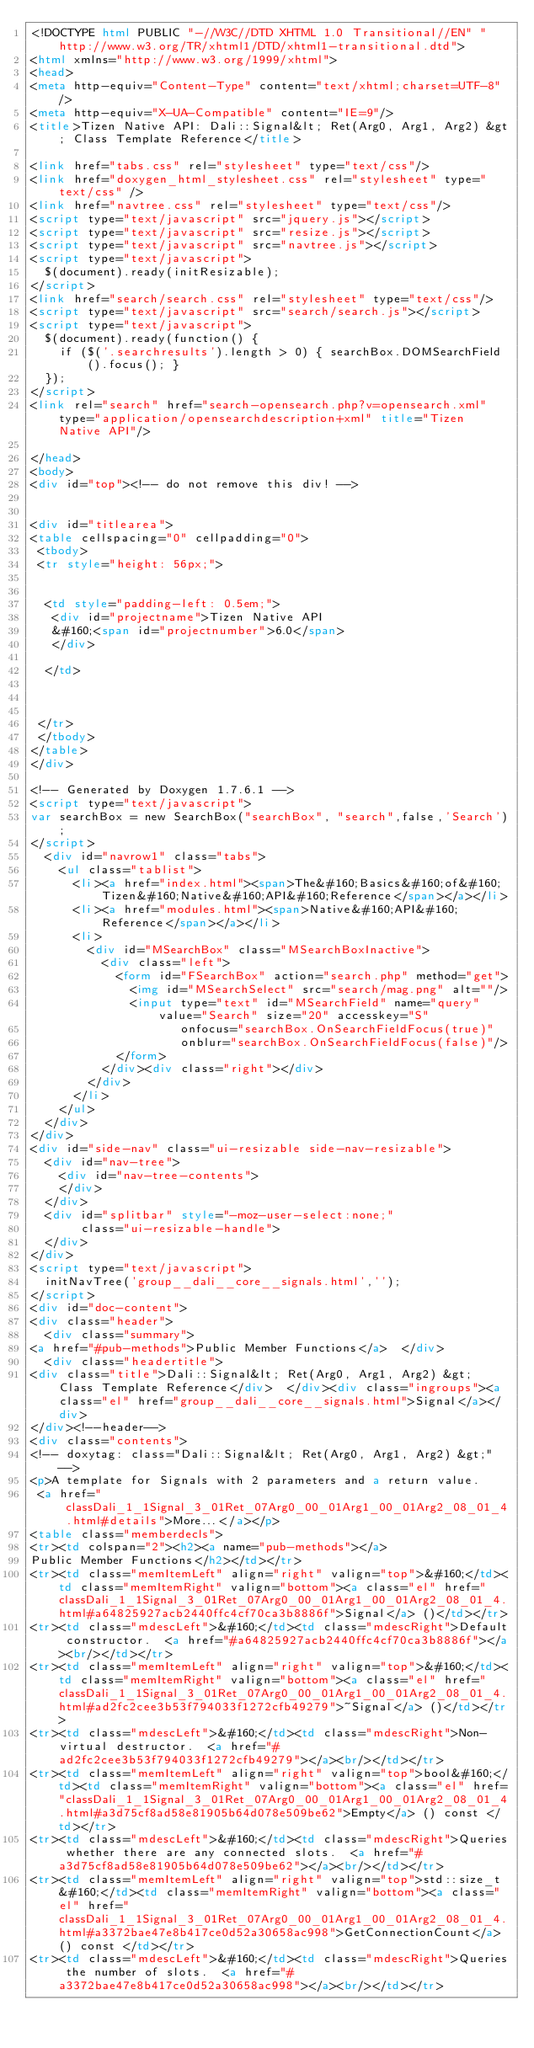<code> <loc_0><loc_0><loc_500><loc_500><_HTML_><!DOCTYPE html PUBLIC "-//W3C//DTD XHTML 1.0 Transitional//EN" "http://www.w3.org/TR/xhtml1/DTD/xhtml1-transitional.dtd">
<html xmlns="http://www.w3.org/1999/xhtml">
<head>
<meta http-equiv="Content-Type" content="text/xhtml;charset=UTF-8"/>
<meta http-equiv="X-UA-Compatible" content="IE=9"/>
<title>Tizen Native API: Dali::Signal&lt; Ret(Arg0, Arg1, Arg2) &gt; Class Template Reference</title>

<link href="tabs.css" rel="stylesheet" type="text/css"/>
<link href="doxygen_html_stylesheet.css" rel="stylesheet" type="text/css" />
<link href="navtree.css" rel="stylesheet" type="text/css"/>
<script type="text/javascript" src="jquery.js"></script>
<script type="text/javascript" src="resize.js"></script>
<script type="text/javascript" src="navtree.js"></script>
<script type="text/javascript">
  $(document).ready(initResizable);
</script>
<link href="search/search.css" rel="stylesheet" type="text/css"/>
<script type="text/javascript" src="search/search.js"></script>
<script type="text/javascript">
  $(document).ready(function() {
    if ($('.searchresults').length > 0) { searchBox.DOMSearchField().focus(); }
  });
</script>
<link rel="search" href="search-opensearch.php?v=opensearch.xml" type="application/opensearchdescription+xml" title="Tizen Native API"/>

</head>
<body>
<div id="top"><!-- do not remove this div! -->


<div id="titlearea">
<table cellspacing="0" cellpadding="0">
 <tbody>
 <tr style="height: 56px;">
  
  
  <td style="padding-left: 0.5em;">
   <div id="projectname">Tizen Native API
   &#160;<span id="projectnumber">6.0</span>
   </div>
   
  </td>
  
  
  
 </tr>
 </tbody>
</table>
</div>

<!-- Generated by Doxygen 1.7.6.1 -->
<script type="text/javascript">
var searchBox = new SearchBox("searchBox", "search",false,'Search');
</script>
  <div id="navrow1" class="tabs">
    <ul class="tablist">
      <li><a href="index.html"><span>The&#160;Basics&#160;of&#160;Tizen&#160;Native&#160;API&#160;Reference</span></a></li>
      <li><a href="modules.html"><span>Native&#160;API&#160;Reference</span></a></li>
      <li>
        <div id="MSearchBox" class="MSearchBoxInactive">
          <div class="left">
            <form id="FSearchBox" action="search.php" method="get">
              <img id="MSearchSelect" src="search/mag.png" alt=""/>
              <input type="text" id="MSearchField" name="query" value="Search" size="20" accesskey="S" 
                     onfocus="searchBox.OnSearchFieldFocus(true)" 
                     onblur="searchBox.OnSearchFieldFocus(false)"/>
            </form>
          </div><div class="right"></div>
        </div>
      </li>
    </ul>
  </div>
</div>
<div id="side-nav" class="ui-resizable side-nav-resizable">
  <div id="nav-tree">
    <div id="nav-tree-contents">
    </div>
  </div>
  <div id="splitbar" style="-moz-user-select:none;" 
       class="ui-resizable-handle">
  </div>
</div>
<script type="text/javascript">
  initNavTree('group__dali__core__signals.html','');
</script>
<div id="doc-content">
<div class="header">
  <div class="summary">
<a href="#pub-methods">Public Member Functions</a>  </div>
  <div class="headertitle">
<div class="title">Dali::Signal&lt; Ret(Arg0, Arg1, Arg2) &gt; Class Template Reference</div>  </div><div class="ingroups"><a class="el" href="group__dali__core__signals.html">Signal</a></div>
</div><!--header-->
<div class="contents">
<!-- doxytag: class="Dali::Signal&lt; Ret(Arg0, Arg1, Arg2) &gt;" -->
<p>A template for Signals with 2 parameters and a return value.  
 <a href="classDali_1_1Signal_3_01Ret_07Arg0_00_01Arg1_00_01Arg2_08_01_4.html#details">More...</a></p>
<table class="memberdecls">
<tr><td colspan="2"><h2><a name="pub-methods"></a>
Public Member Functions</h2></td></tr>
<tr><td class="memItemLeft" align="right" valign="top">&#160;</td><td class="memItemRight" valign="bottom"><a class="el" href="classDali_1_1Signal_3_01Ret_07Arg0_00_01Arg1_00_01Arg2_08_01_4.html#a64825927acb2440ffc4cf70ca3b8886f">Signal</a> ()</td></tr>
<tr><td class="mdescLeft">&#160;</td><td class="mdescRight">Default constructor.  <a href="#a64825927acb2440ffc4cf70ca3b8886f"></a><br/></td></tr>
<tr><td class="memItemLeft" align="right" valign="top">&#160;</td><td class="memItemRight" valign="bottom"><a class="el" href="classDali_1_1Signal_3_01Ret_07Arg0_00_01Arg1_00_01Arg2_08_01_4.html#ad2fc2cee3b53f794033f1272cfb49279">~Signal</a> ()</td></tr>
<tr><td class="mdescLeft">&#160;</td><td class="mdescRight">Non-virtual destructor.  <a href="#ad2fc2cee3b53f794033f1272cfb49279"></a><br/></td></tr>
<tr><td class="memItemLeft" align="right" valign="top">bool&#160;</td><td class="memItemRight" valign="bottom"><a class="el" href="classDali_1_1Signal_3_01Ret_07Arg0_00_01Arg1_00_01Arg2_08_01_4.html#a3d75cf8ad58e81905b64d078e509be62">Empty</a> () const </td></tr>
<tr><td class="mdescLeft">&#160;</td><td class="mdescRight">Queries whether there are any connected slots.  <a href="#a3d75cf8ad58e81905b64d078e509be62"></a><br/></td></tr>
<tr><td class="memItemLeft" align="right" valign="top">std::size_t&#160;</td><td class="memItemRight" valign="bottom"><a class="el" href="classDali_1_1Signal_3_01Ret_07Arg0_00_01Arg1_00_01Arg2_08_01_4.html#a3372bae47e8b417ce0d52a30658ac998">GetConnectionCount</a> () const </td></tr>
<tr><td class="mdescLeft">&#160;</td><td class="mdescRight">Queries the number of slots.  <a href="#a3372bae47e8b417ce0d52a30658ac998"></a><br/></td></tr></code> 